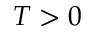<formula> <loc_0><loc_0><loc_500><loc_500>T > 0</formula> 